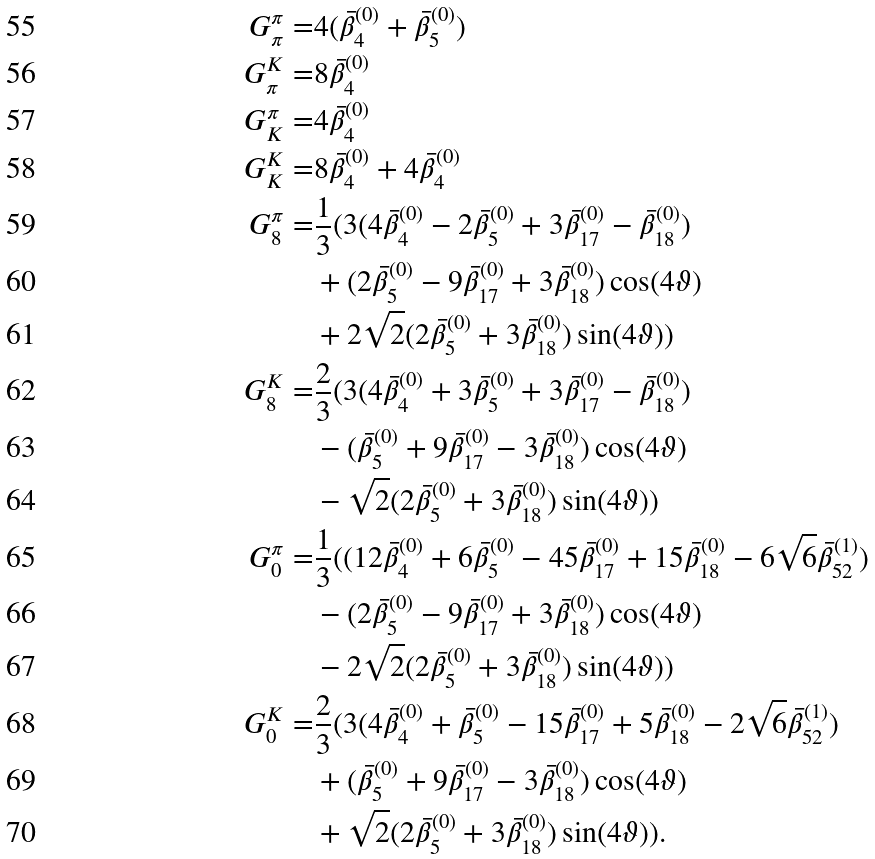<formula> <loc_0><loc_0><loc_500><loc_500>G _ { \pi } ^ { \pi } = & 4 ( \bar { \beta } _ { 4 } ^ { ( 0 ) } + \bar { \beta } _ { 5 } ^ { ( 0 ) } ) \\ G _ { \pi } ^ { K } = & 8 \bar { \beta } _ { 4 } ^ { ( 0 ) } \\ G _ { K } ^ { \pi } = & 4 \bar { \beta } _ { 4 } ^ { ( 0 ) } \\ G _ { K } ^ { K } = & 8 \bar { \beta } _ { 4 } ^ { ( 0 ) } + 4 \bar { \beta } _ { 4 } ^ { ( 0 ) } \\ G _ { 8 } ^ { \pi } = & \frac { 1 } { 3 } ( 3 ( 4 \bar { \beta } _ { 4 } ^ { ( 0 ) } - 2 \bar { \beta } _ { 5 } ^ { ( 0 ) } + 3 \bar { \beta } _ { 1 7 } ^ { ( 0 ) } - \bar { \beta } _ { 1 8 } ^ { ( 0 ) } ) \\ & + ( 2 \bar { \beta } _ { 5 } ^ { ( 0 ) } - 9 \bar { \beta } _ { 1 7 } ^ { ( 0 ) } + 3 \bar { \beta } _ { 1 8 } ^ { ( 0 ) } ) \cos ( 4 \vartheta ) \\ & + 2 \sqrt { 2 } ( 2 \bar { \beta } _ { 5 } ^ { ( 0 ) } + 3 \bar { \beta } _ { 1 8 } ^ { ( 0 ) } ) \sin ( 4 \vartheta ) ) \\ G _ { 8 } ^ { K } = & \frac { 2 } { 3 } ( 3 ( 4 \bar { \beta } _ { 4 } ^ { ( 0 ) } + 3 \bar { \beta } _ { 5 } ^ { ( 0 ) } + 3 \bar { \beta } _ { 1 7 } ^ { ( 0 ) } - \bar { \beta } _ { 1 8 } ^ { ( 0 ) } ) \\ & - ( \bar { \beta } _ { 5 } ^ { ( 0 ) } + 9 \bar { \beta } _ { 1 7 } ^ { ( 0 ) } - 3 \bar { \beta } _ { 1 8 } ^ { ( 0 ) } ) \cos ( 4 \vartheta ) \\ & - \sqrt { 2 } ( 2 \bar { \beta } _ { 5 } ^ { ( 0 ) } + 3 \bar { \beta } _ { 1 8 } ^ { ( 0 ) } ) \sin ( 4 \vartheta ) ) \\ G _ { 0 } ^ { \pi } = & \frac { 1 } { 3 } ( ( 1 2 \bar { \beta } _ { 4 } ^ { ( 0 ) } + 6 \bar { \beta } _ { 5 } ^ { ( 0 ) } - 4 5 \bar { \beta } _ { 1 7 } ^ { ( 0 ) } + 1 5 \bar { \beta } _ { 1 8 } ^ { ( 0 ) } - 6 \sqrt { 6 } \bar { \beta } _ { 5 2 } ^ { ( 1 ) } ) \\ & - ( 2 \bar { \beta } _ { 5 } ^ { ( 0 ) } - 9 \bar { \beta } _ { 1 7 } ^ { ( 0 ) } + 3 \bar { \beta } _ { 1 8 } ^ { ( 0 ) } ) \cos ( 4 \vartheta ) \\ & - 2 \sqrt { 2 } ( 2 \bar { \beta } _ { 5 } ^ { ( 0 ) } + 3 \bar { \beta } _ { 1 8 } ^ { ( 0 ) } ) \sin ( 4 \vartheta ) ) \\ G _ { 0 } ^ { K } = & \frac { 2 } { 3 } ( 3 ( 4 \bar { \beta } _ { 4 } ^ { ( 0 ) } + \bar { \beta } _ { 5 } ^ { ( 0 ) } - 1 5 \bar { \beta } _ { 1 7 } ^ { ( 0 ) } + 5 \bar { \beta } _ { 1 8 } ^ { ( 0 ) } - 2 \sqrt { 6 } \bar { \beta } _ { 5 2 } ^ { ( 1 ) } ) \\ & + ( \bar { \beta } _ { 5 } ^ { ( 0 ) } + 9 \bar { \beta } _ { 1 7 } ^ { ( 0 ) } - 3 \bar { \beta } _ { 1 8 } ^ { ( 0 ) } ) \cos ( 4 \vartheta ) \\ & + \sqrt { 2 } ( 2 \bar { \beta } _ { 5 } ^ { ( 0 ) } + 3 \bar { \beta } _ { 1 8 } ^ { ( 0 ) } ) \sin ( 4 \vartheta ) ) .</formula> 